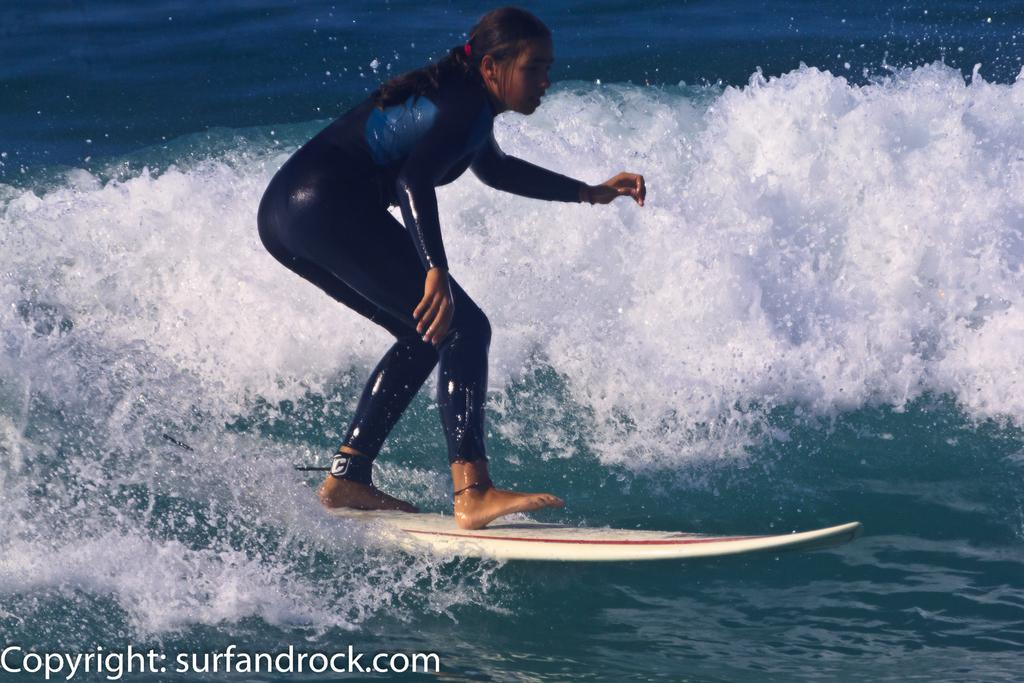Who is the main subject in the image? There is a girl in the image. What is the girl doing in the image? The girl is standing on a surfboard and surfing in the water. What is the color of the water in the image? The water is blue in color. What can be observed about the tides in the water? There are white-colored tides in the water. Where is the scarecrow located in the image? There is no scarecrow present in the image. What type of fruit is the girl holding while surfing in the image? The girl is not holding any fruit in the image; she is standing on a surfboard and surfing in the water. 